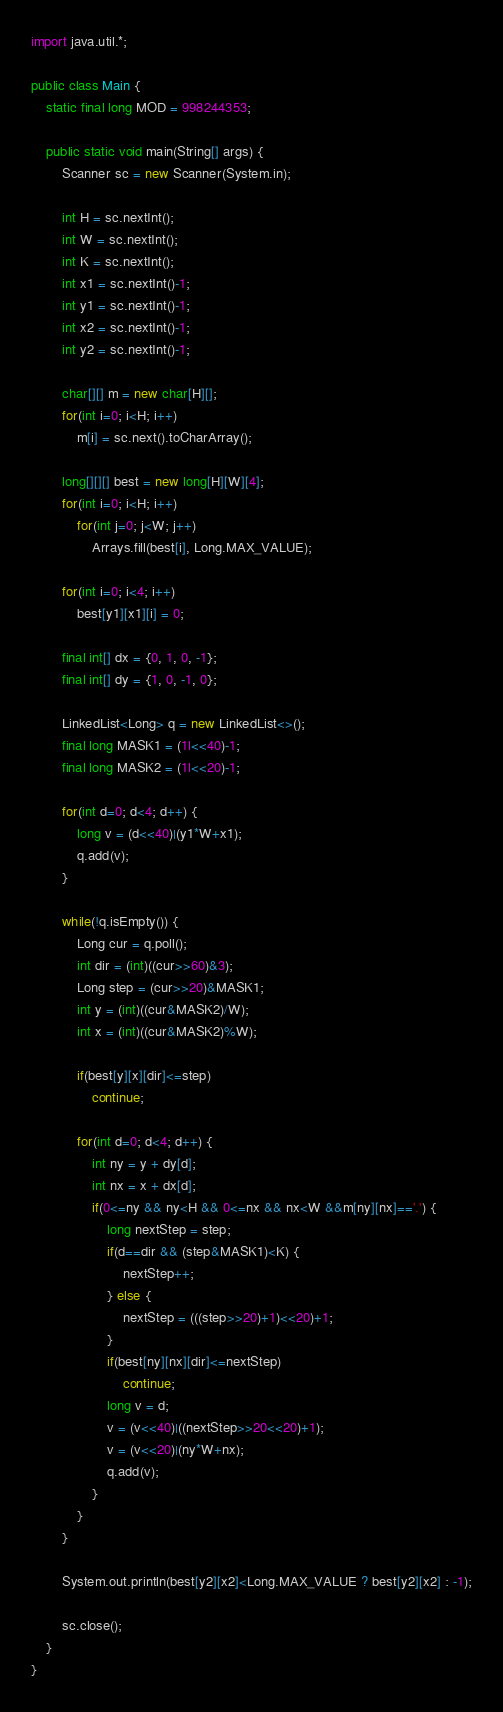Convert code to text. <code><loc_0><loc_0><loc_500><loc_500><_Java_>import java.util.*;

public class Main {
	static final long MOD = 998244353;
	
	public static void main(String[] args) {
		Scanner sc = new Scanner(System.in);

		int H = sc.nextInt();
		int W = sc.nextInt();
		int K = sc.nextInt();
		int x1 = sc.nextInt()-1;
		int y1 = sc.nextInt()-1;
		int x2 = sc.nextInt()-1;
		int y2 = sc.nextInt()-1;

		char[][] m = new char[H][];
		for(int i=0; i<H; i++)
			m[i] = sc.next().toCharArray();

		long[][][] best = new long[H][W][4];
		for(int i=0; i<H; i++)
			for(int j=0; j<W; j++)
				Arrays.fill(best[i], Long.MAX_VALUE);
		
		for(int i=0; i<4; i++)
			best[y1][x1][i] = 0;
		
		final int[] dx = {0, 1, 0, -1};
		final int[] dy = {1, 0, -1, 0};
		
		LinkedList<Long> q = new LinkedList<>();
		final long MASK1 = (1l<<40)-1;
		final long MASK2 = (1l<<20)-1;
		
		for(int d=0; d<4; d++) {
			long v = (d<<40)|(y1*W+x1);
			q.add(v);
		}
		
		while(!q.isEmpty()) {
			Long cur = q.poll();
			int dir = (int)((cur>>60)&3);
			Long step = (cur>>20)&MASK1;
			int y = (int)((cur&MASK2)/W);
			int x = (int)((cur&MASK2)%W);
			
			if(best[y][x][dir]<=step)
				continue;
			
			for(int d=0; d<4; d++) {
				int ny = y + dy[d];
				int nx = x + dx[d];
				if(0<=ny && ny<H && 0<=nx && nx<W &&m[ny][nx]=='.') {
					long nextStep = step;
					if(d==dir && (step&MASK1)<K) {
						nextStep++;
					} else {
						nextStep = (((step>>20)+1)<<20)+1;
					}
					if(best[ny][nx][dir]<=nextStep)
						continue;
					long v = d;
					v = (v<<40)|((nextStep>>20<<20)+1);
					v = (v<<20)|(ny*W+nx);
					q.add(v);
				}
			}
		}
		
		System.out.println(best[y2][x2]<Long.MAX_VALUE ? best[y2][x2] : -1);

		sc.close();
	}
}
</code> 